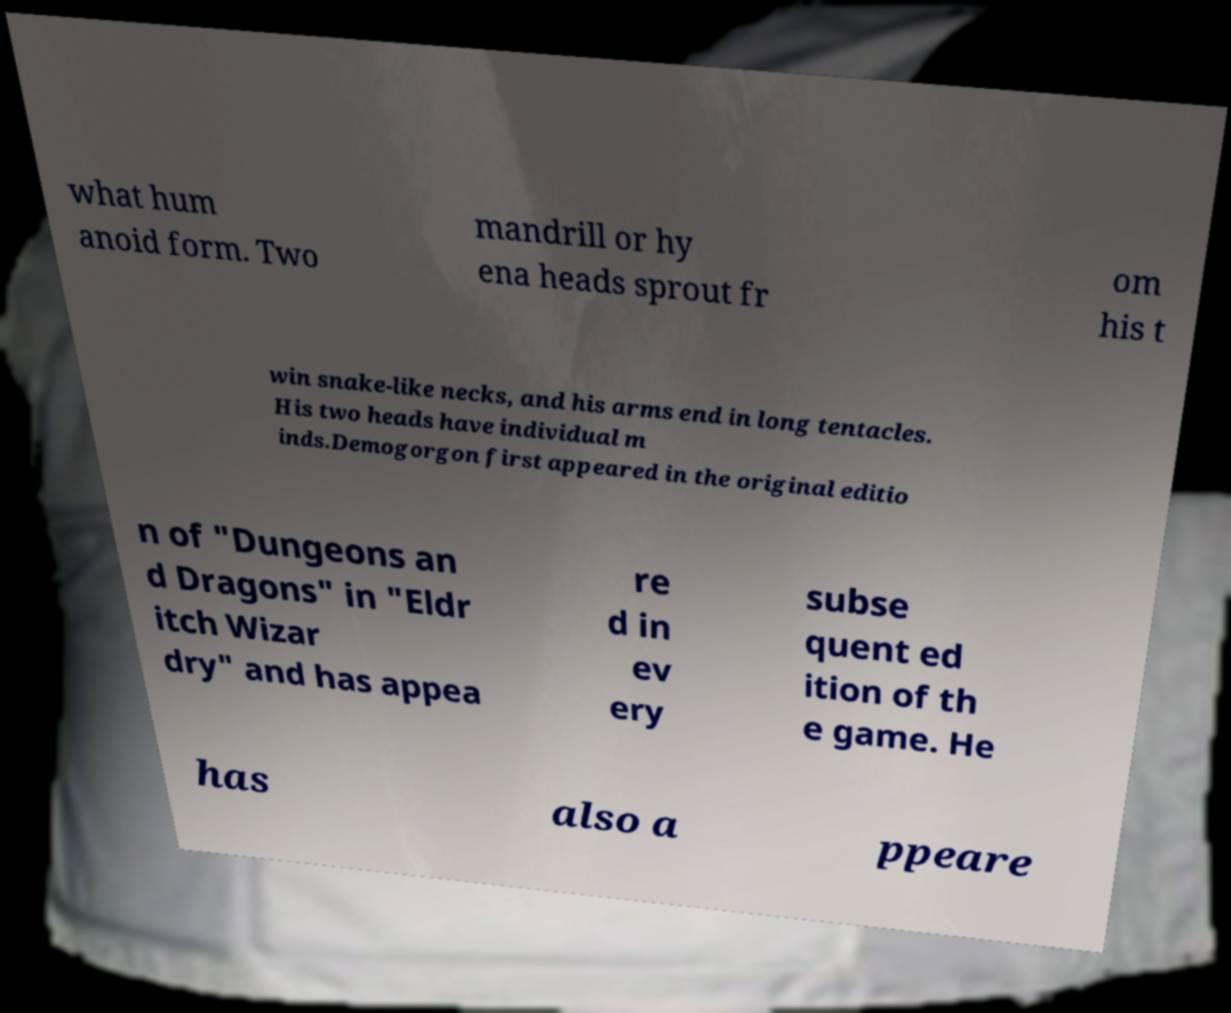What messages or text are displayed in this image? I need them in a readable, typed format. what hum anoid form. Two mandrill or hy ena heads sprout fr om his t win snake-like necks, and his arms end in long tentacles. His two heads have individual m inds.Demogorgon first appeared in the original editio n of "Dungeons an d Dragons" in "Eldr itch Wizar dry" and has appea re d in ev ery subse quent ed ition of th e game. He has also a ppeare 